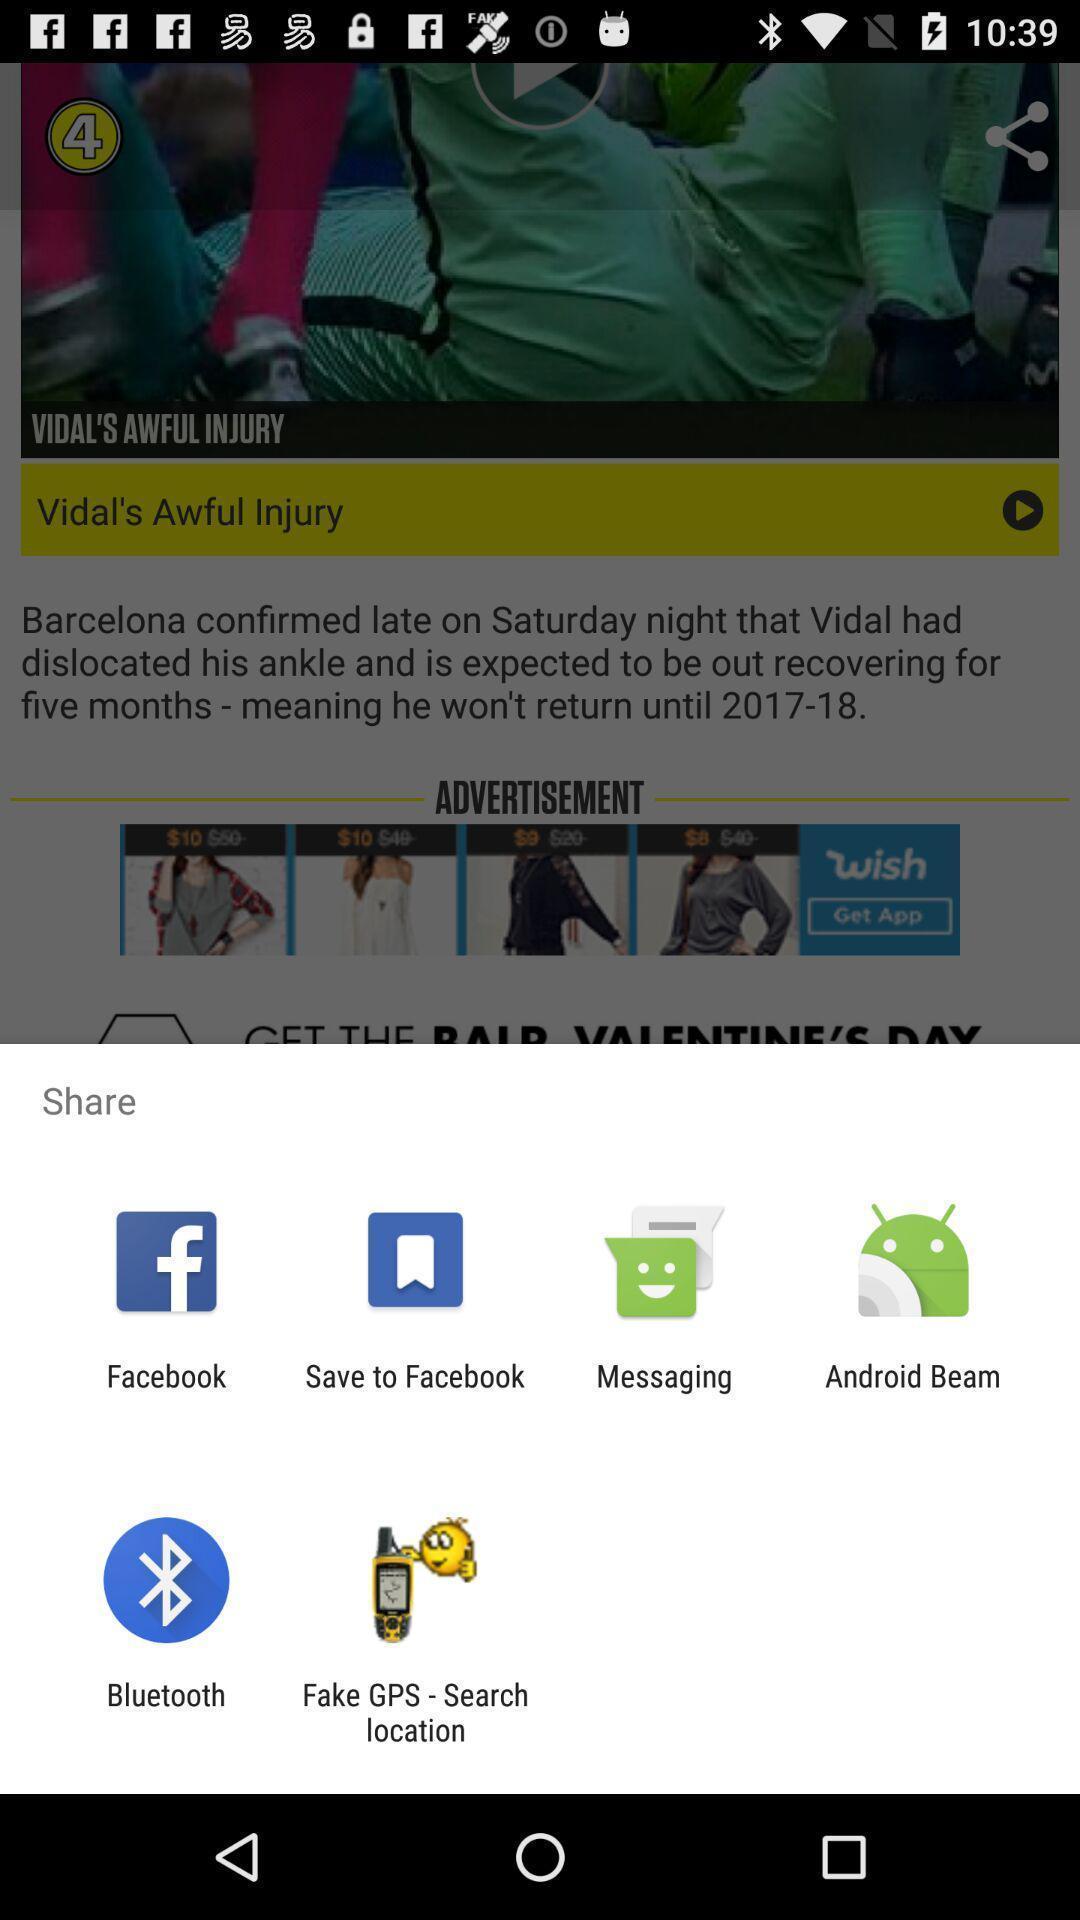Summarize the main components in this picture. Pop-up to choose an option to share via an app. 